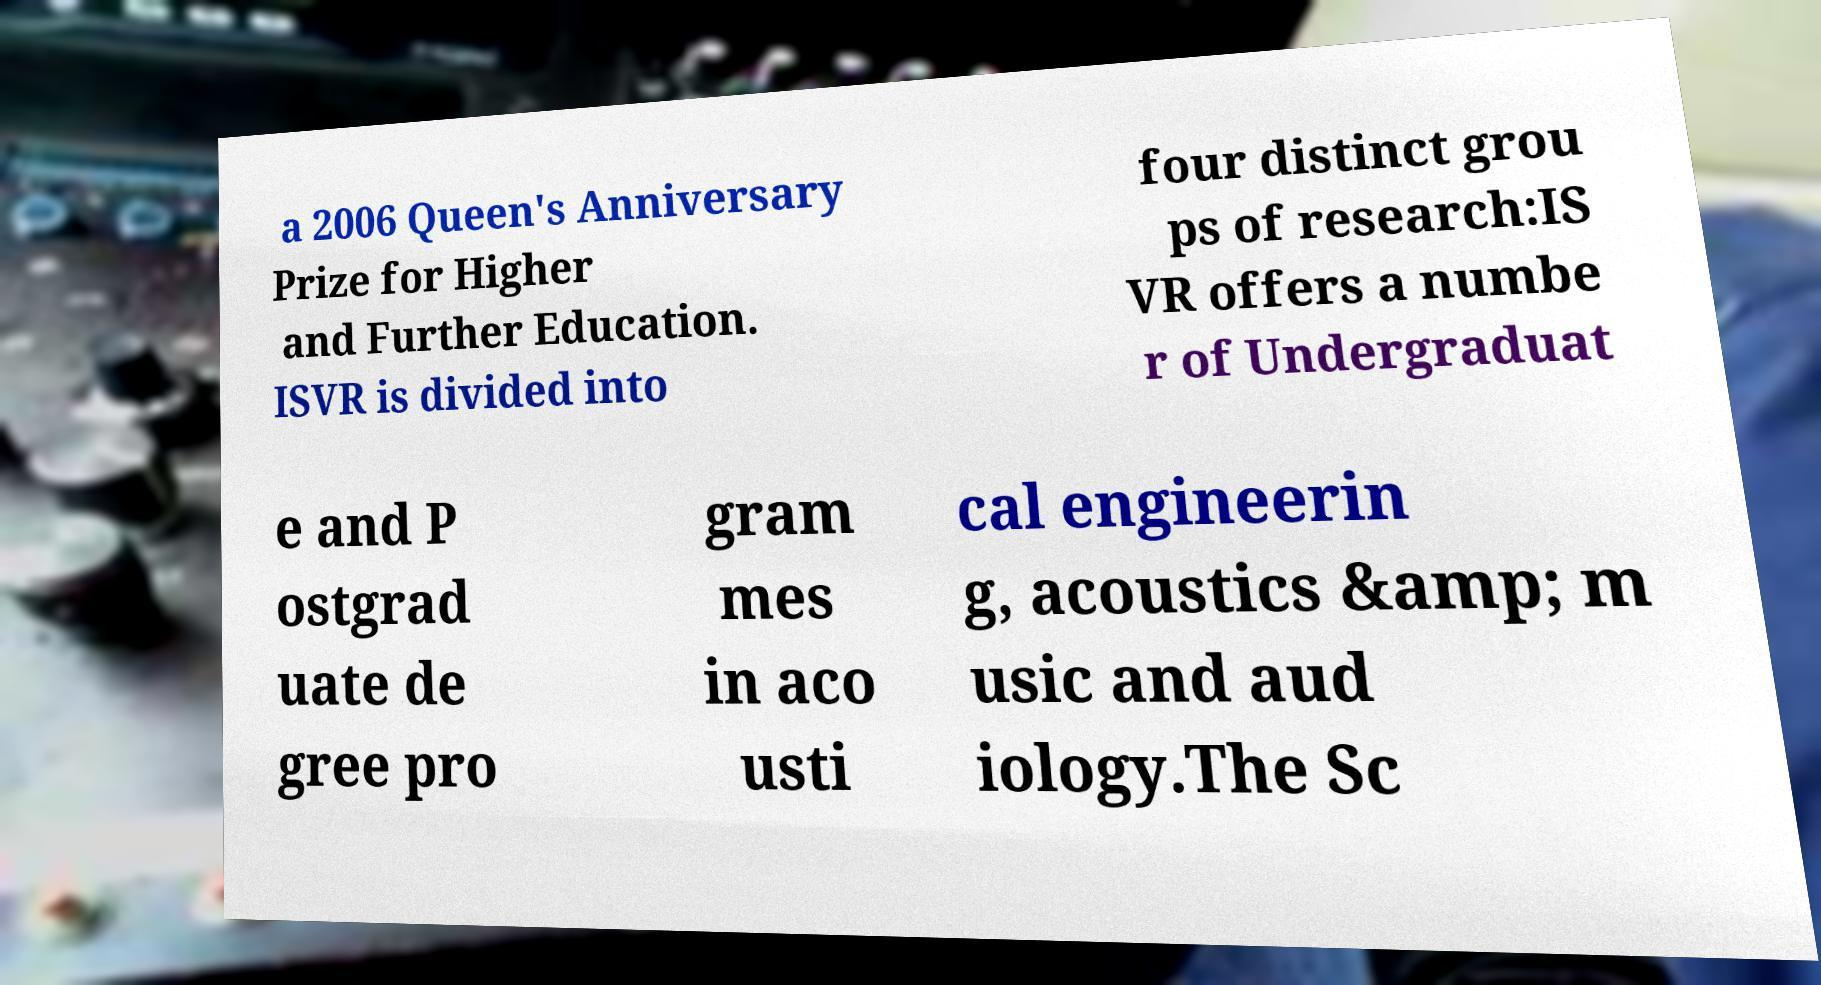Could you assist in decoding the text presented in this image and type it out clearly? a 2006 Queen's Anniversary Prize for Higher and Further Education. ISVR is divided into four distinct grou ps of research:IS VR offers a numbe r of Undergraduat e and P ostgrad uate de gree pro gram mes in aco usti cal engineerin g, acoustics &amp; m usic and aud iology.The Sc 